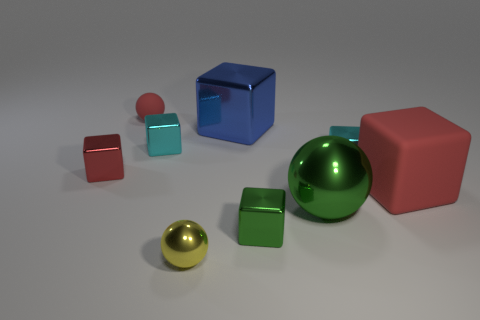Subtract all tiny green cubes. How many cubes are left? 5 Subtract all red cubes. How many cubes are left? 4 Add 1 big red things. How many objects exist? 10 Subtract all green balls. Subtract all gray cubes. How many balls are left? 2 Subtract all blue blocks. How many green balls are left? 1 Subtract all tiny blue shiny balls. Subtract all matte blocks. How many objects are left? 8 Add 8 big metallic objects. How many big metallic objects are left? 10 Add 5 small red matte objects. How many small red matte objects exist? 6 Subtract 0 purple blocks. How many objects are left? 9 Subtract all cubes. How many objects are left? 3 